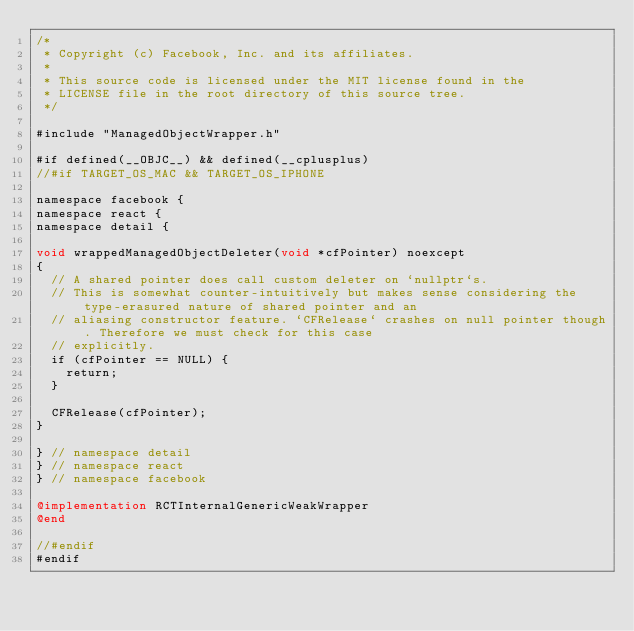<code> <loc_0><loc_0><loc_500><loc_500><_ObjectiveC_>/*
 * Copyright (c) Facebook, Inc. and its affiliates.
 *
 * This source code is licensed under the MIT license found in the
 * LICENSE file in the root directory of this source tree.
 */

#include "ManagedObjectWrapper.h"

#if defined(__OBJC__) && defined(__cplusplus)
//#if TARGET_OS_MAC && TARGET_OS_IPHONE

namespace facebook {
namespace react {
namespace detail {

void wrappedManagedObjectDeleter(void *cfPointer) noexcept
{
  // A shared pointer does call custom deleter on `nullptr`s.
  // This is somewhat counter-intuitively but makes sense considering the type-erasured nature of shared pointer and an
  // aliasing constructor feature. `CFRelease` crashes on null pointer though. Therefore we must check for this case
  // explicitly.
  if (cfPointer == NULL) {
    return;
  }

  CFRelease(cfPointer);
}

} // namespace detail
} // namespace react
} // namespace facebook

@implementation RCTInternalGenericWeakWrapper
@end

//#endif
#endif
</code> 